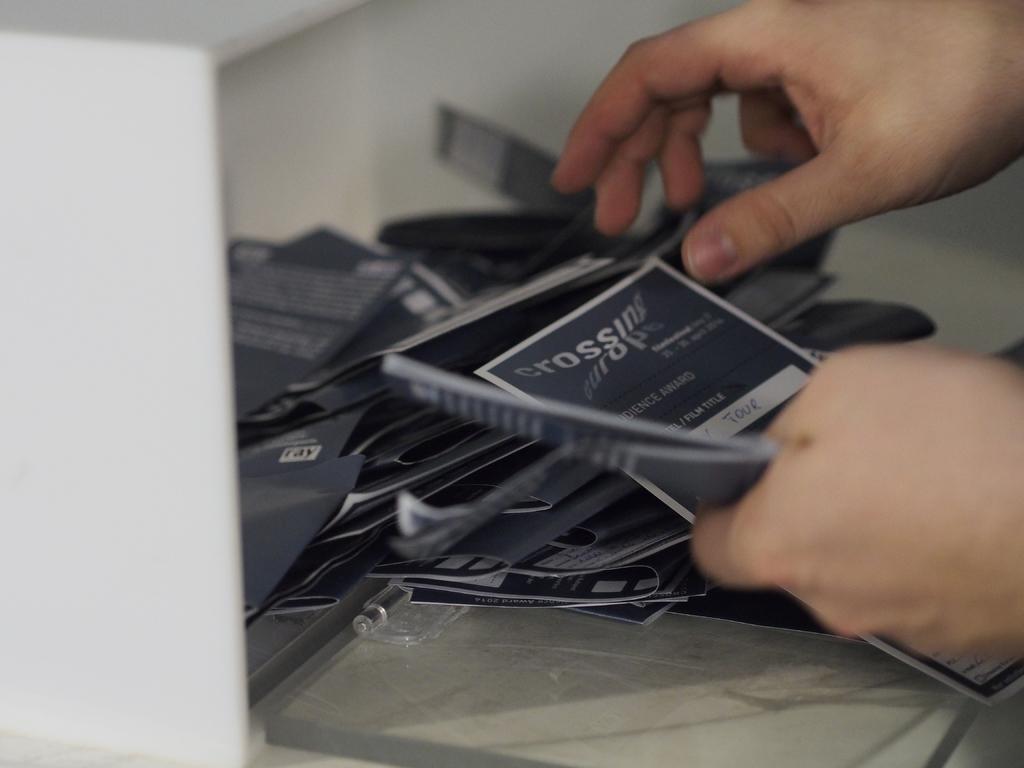Could you give a brief overview of what you see in this image? In this image, we can see person hands. There are some cards in the middle of the image. In the background, image is blurred. 